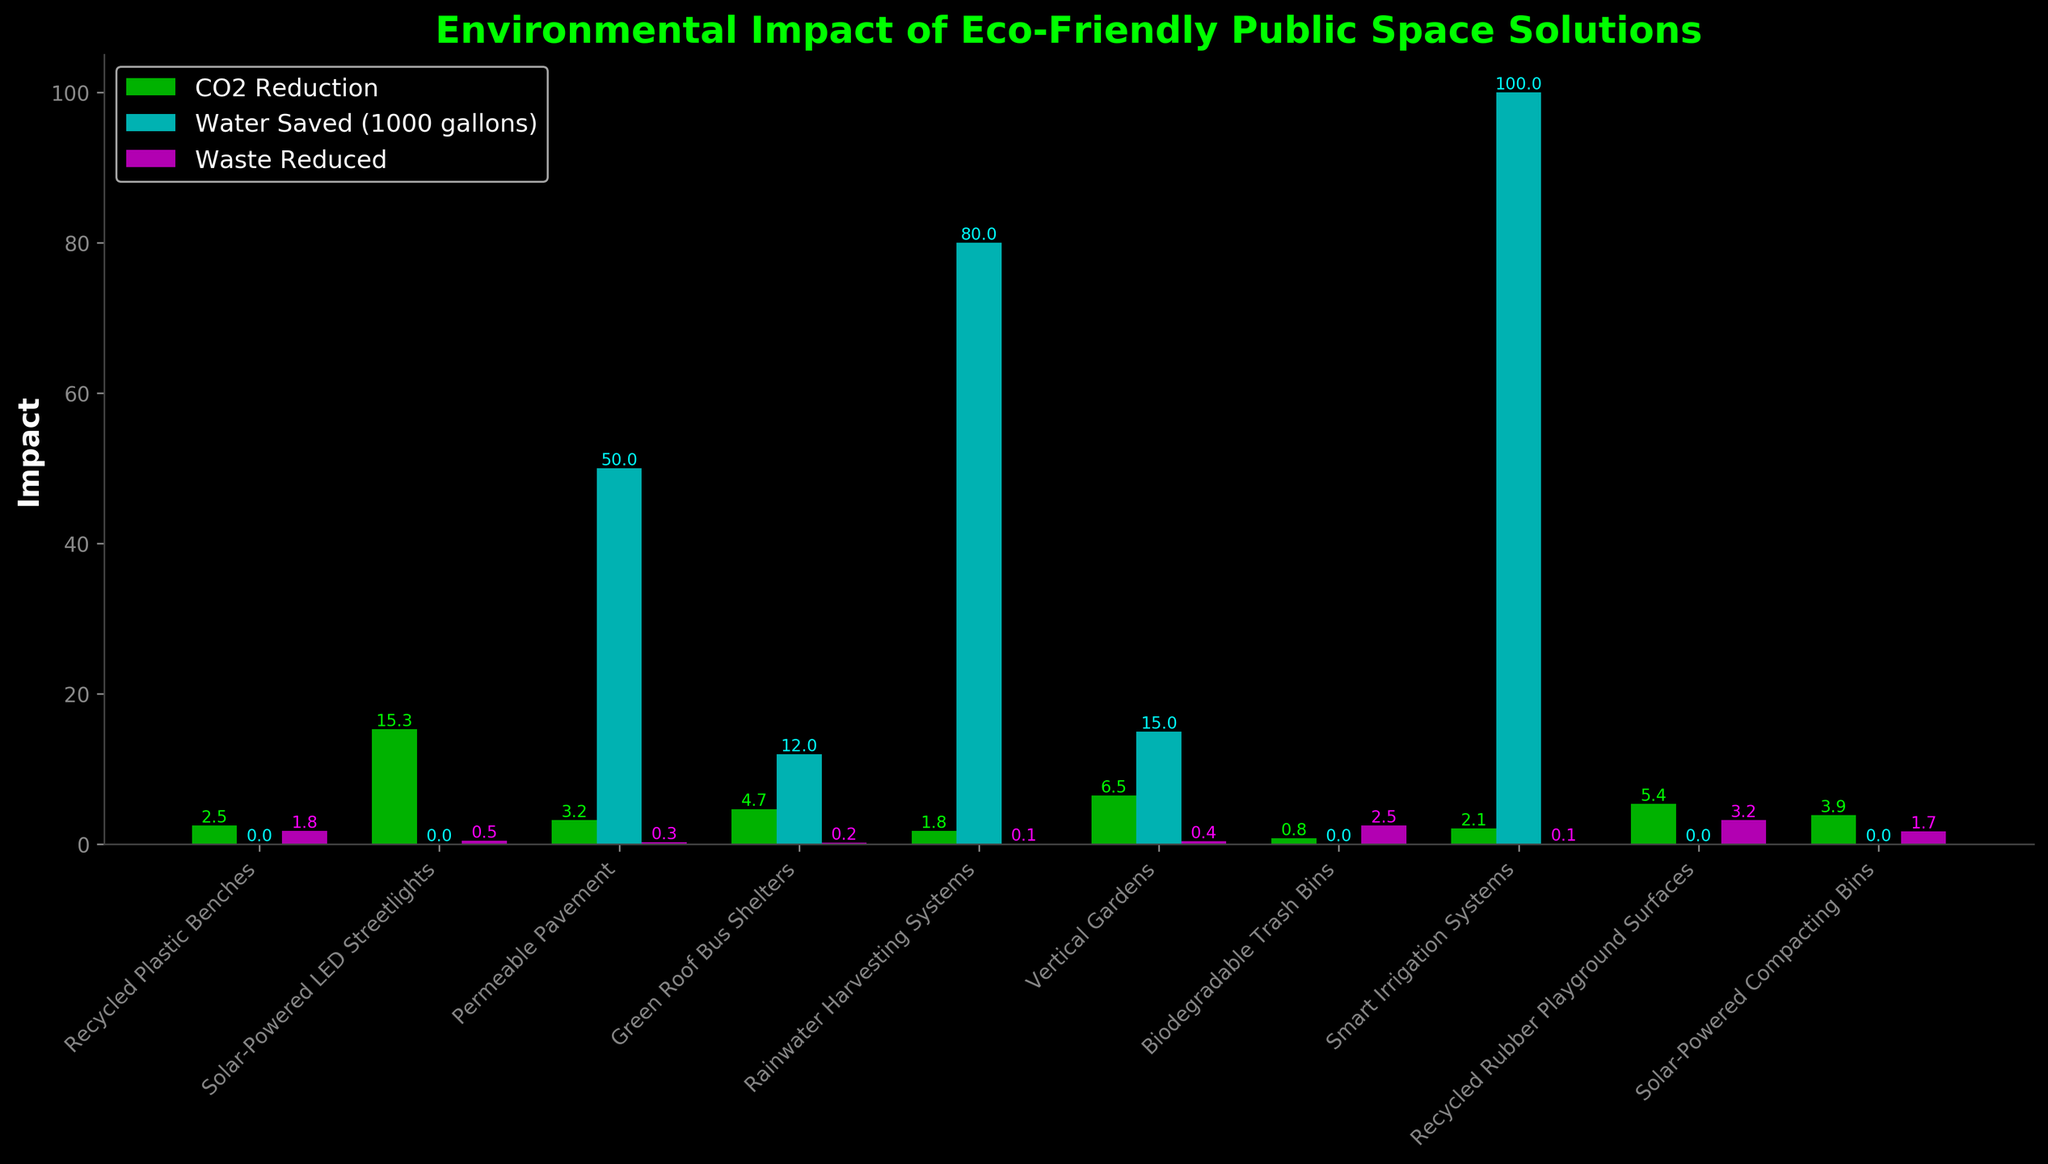What's the total CO2 reduction from all solutions combined? Sum the CO2 reduction values for all solutions: 2.5 + 15.3 + 3.2 + 4.7 + 1.8 + 6.5 + 0.8 + 2.1 + 5.4 + 3.9 = 46.2 tons/year
Answer: 46.2 tons/year Which solution has saved the most water? Compare the water saved by each solution and identify the highest value: Rainwater Harvesting Systems saved 80,000 gallons/year.
Answer: Rainwater Harvesting Systems What is the average waste reduction for all listed solutions? Sum the waste reduction values and divide by the number of solutions: (1.8 + 0.5 + 0.3 + 0.2 + 0.1 + 0.4 + 2.5 + 0.1 + 3.2 + 1.7) = 10.8 tons/year. Since there are 10 solutions, the average is 10.8 / 10 = 1.08 tons/year
Answer: 1.08 tons/year Which two solutions together reduce the most CO2 emissions? Identify the two solutions with the highest CO2 reduction values: (Solar-Powered LED Streetlights and Vertical Gardens), then sum their values: 15.3 + 6.5 = 21.8 tons/year
Answer: Solar-Powered LED Streetlights and Vertical Gardens How does the CO2 reduction of permeable pavement compare to that of green roof bus shelters? Permeable Pavement has a CO2 reduction of 3.2 tons/year, while Green Roof Bus Shelters have a CO2 reduction of 4.7 tons/year. Thus, Green Roof Bus Shelters have a higher CO2 reduction.
Answer: Green Roof Bus Shelters Which solution contributes the most to waste reduction and how much does it reduce? Compare the waste reduction values and identify the highest value: Recycled Rubber Playground Surfaces reduce 3.2 tons/year of waste.
Answer: Recycled Rubber Playground Surfaces, 3.2 tons/year What is the combined water conservation of vertical gardens, green roof bus shelters, and smart irrigation systems? Sum the water saved for these three solutions: 15,000 + 12,000 + 100,000 = 127,000 gallons/year
Answer: 127,000 gallons/year Which solutions do not save water? Identify the solutions with zero water saved: Recycled Plastic Benches, Solar-Powered LED Streetlights, Biodegradable Trash Bins, Recycled Rubber Playground Surfaces, Solar-Powered Compacting Bins.
Answer: Recycled Plastic Benches, Solar-Powered LED Streetlights, Biodegradable Trash Bins, Recycled Rubber Playground Surfaces, Solar-Powered Compacting Bins What is the difference in CO2 reduction between the solution with the highest CO2 reduction and the solution with the lowest CO2 reduction? The solution with the highest CO2 reduction is Solar-Powered LED Streetlights (15.3 tons/year) and the solution with the lowest CO2 reduction is Biodegradable Trash Bins (0.8 tons/year). The difference is 15.3 - 0.8 = 14.5 tons/year.
Answer: 14.5 tons/year 